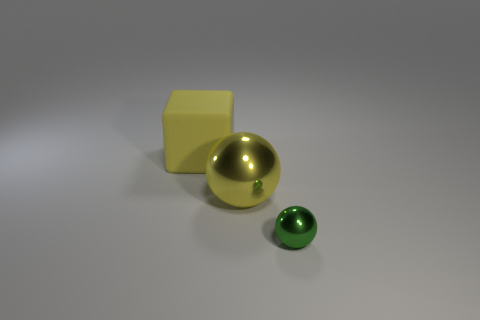Add 2 big yellow shiny balls. How many objects exist? 5 Subtract all cubes. How many objects are left? 2 Subtract all big things. Subtract all big rubber things. How many objects are left? 0 Add 2 balls. How many balls are left? 4 Add 3 shiny things. How many shiny things exist? 5 Subtract 0 blue spheres. How many objects are left? 3 